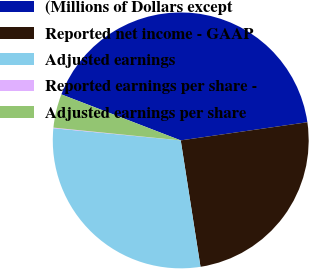Convert chart to OTSL. <chart><loc_0><loc_0><loc_500><loc_500><pie_chart><fcel>(Millions of Dollars except<fcel>Reported net income - GAAP<fcel>Adjusted earnings<fcel>Reported earnings per share -<fcel>Adjusted earnings per share<nl><fcel>41.88%<fcel>24.8%<fcel>28.98%<fcel>0.08%<fcel>4.26%<nl></chart> 